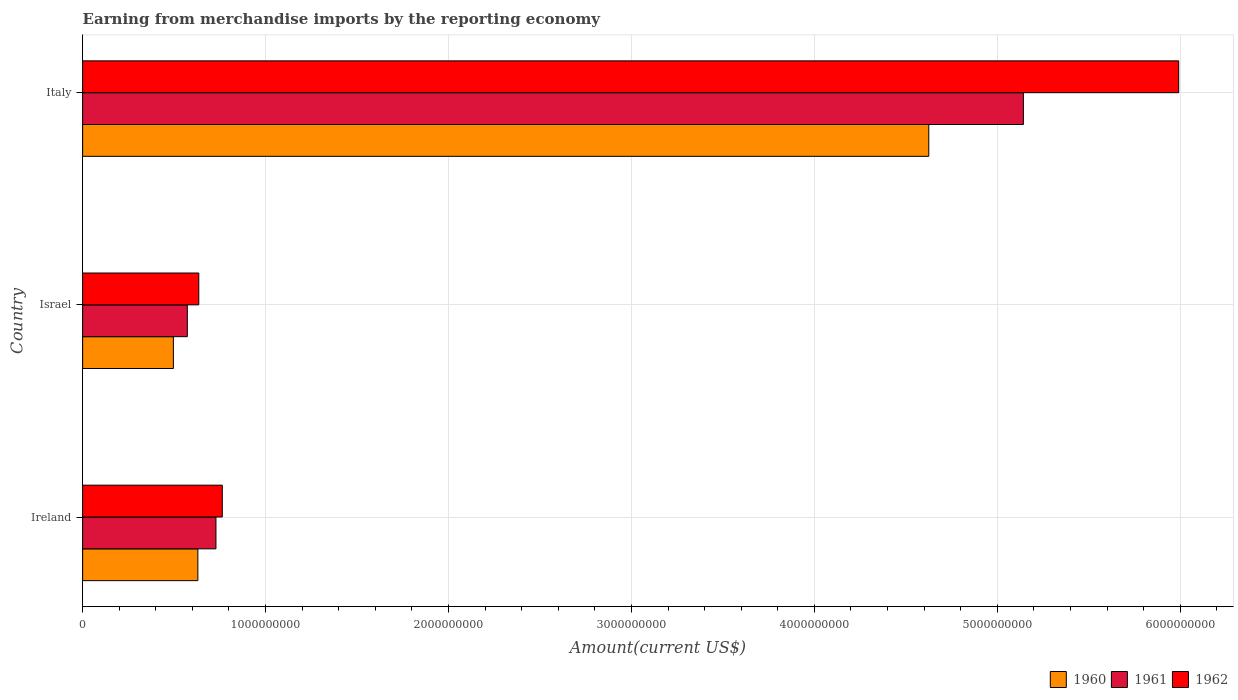How many different coloured bars are there?
Offer a very short reply. 3. Are the number of bars per tick equal to the number of legend labels?
Ensure brevity in your answer.  Yes. How many bars are there on the 2nd tick from the bottom?
Offer a terse response. 3. In how many cases, is the number of bars for a given country not equal to the number of legend labels?
Offer a very short reply. 0. What is the amount earned from merchandise imports in 1961 in Ireland?
Your answer should be very brief. 7.29e+08. Across all countries, what is the maximum amount earned from merchandise imports in 1960?
Offer a very short reply. 4.63e+09. Across all countries, what is the minimum amount earned from merchandise imports in 1960?
Offer a terse response. 4.96e+08. What is the total amount earned from merchandise imports in 1962 in the graph?
Give a very brief answer. 7.39e+09. What is the difference between the amount earned from merchandise imports in 1962 in Israel and that in Italy?
Keep it short and to the point. -5.36e+09. What is the difference between the amount earned from merchandise imports in 1962 in Israel and the amount earned from merchandise imports in 1961 in Ireland?
Your answer should be compact. -9.39e+07. What is the average amount earned from merchandise imports in 1960 per country?
Offer a very short reply. 1.92e+09. What is the difference between the amount earned from merchandise imports in 1960 and amount earned from merchandise imports in 1962 in Israel?
Offer a very short reply. -1.39e+08. What is the ratio of the amount earned from merchandise imports in 1960 in Ireland to that in Italy?
Offer a terse response. 0.14. Is the amount earned from merchandise imports in 1962 in Ireland less than that in Israel?
Your answer should be very brief. No. What is the difference between the highest and the second highest amount earned from merchandise imports in 1961?
Your answer should be very brief. 4.41e+09. What is the difference between the highest and the lowest amount earned from merchandise imports in 1960?
Give a very brief answer. 4.13e+09. Is the sum of the amount earned from merchandise imports in 1962 in Israel and Italy greater than the maximum amount earned from merchandise imports in 1960 across all countries?
Offer a very short reply. Yes. What does the 1st bar from the top in Israel represents?
Provide a short and direct response. 1962. What does the 1st bar from the bottom in Ireland represents?
Ensure brevity in your answer.  1960. Is it the case that in every country, the sum of the amount earned from merchandise imports in 1960 and amount earned from merchandise imports in 1961 is greater than the amount earned from merchandise imports in 1962?
Provide a succinct answer. Yes. How many bars are there?
Your answer should be very brief. 9. Are all the bars in the graph horizontal?
Make the answer very short. Yes. Does the graph contain any zero values?
Your answer should be compact. No. What is the title of the graph?
Offer a very short reply. Earning from merchandise imports by the reporting economy. What is the label or title of the X-axis?
Make the answer very short. Amount(current US$). What is the label or title of the Y-axis?
Give a very brief answer. Country. What is the Amount(current US$) in 1960 in Ireland?
Keep it short and to the point. 6.30e+08. What is the Amount(current US$) of 1961 in Ireland?
Your response must be concise. 7.29e+08. What is the Amount(current US$) in 1962 in Ireland?
Provide a short and direct response. 7.64e+08. What is the Amount(current US$) in 1960 in Israel?
Ensure brevity in your answer.  4.96e+08. What is the Amount(current US$) in 1961 in Israel?
Offer a very short reply. 5.72e+08. What is the Amount(current US$) of 1962 in Israel?
Your response must be concise. 6.35e+08. What is the Amount(current US$) of 1960 in Italy?
Give a very brief answer. 4.63e+09. What is the Amount(current US$) in 1961 in Italy?
Your answer should be very brief. 5.14e+09. What is the Amount(current US$) in 1962 in Italy?
Keep it short and to the point. 5.99e+09. Across all countries, what is the maximum Amount(current US$) of 1960?
Give a very brief answer. 4.63e+09. Across all countries, what is the maximum Amount(current US$) of 1961?
Your answer should be very brief. 5.14e+09. Across all countries, what is the maximum Amount(current US$) in 1962?
Make the answer very short. 5.99e+09. Across all countries, what is the minimum Amount(current US$) in 1960?
Offer a very short reply. 4.96e+08. Across all countries, what is the minimum Amount(current US$) in 1961?
Give a very brief answer. 5.72e+08. Across all countries, what is the minimum Amount(current US$) in 1962?
Your response must be concise. 6.35e+08. What is the total Amount(current US$) in 1960 in the graph?
Give a very brief answer. 5.75e+09. What is the total Amount(current US$) of 1961 in the graph?
Your answer should be very brief. 6.44e+09. What is the total Amount(current US$) in 1962 in the graph?
Your answer should be very brief. 7.39e+09. What is the difference between the Amount(current US$) of 1960 in Ireland and that in Israel?
Make the answer very short. 1.34e+08. What is the difference between the Amount(current US$) of 1961 in Ireland and that in Israel?
Offer a very short reply. 1.56e+08. What is the difference between the Amount(current US$) of 1962 in Ireland and that in Israel?
Your answer should be compact. 1.29e+08. What is the difference between the Amount(current US$) of 1960 in Ireland and that in Italy?
Ensure brevity in your answer.  -4.00e+09. What is the difference between the Amount(current US$) of 1961 in Ireland and that in Italy?
Give a very brief answer. -4.41e+09. What is the difference between the Amount(current US$) of 1962 in Ireland and that in Italy?
Make the answer very short. -5.23e+09. What is the difference between the Amount(current US$) in 1960 in Israel and that in Italy?
Ensure brevity in your answer.  -4.13e+09. What is the difference between the Amount(current US$) in 1961 in Israel and that in Italy?
Your response must be concise. -4.57e+09. What is the difference between the Amount(current US$) of 1962 in Israel and that in Italy?
Provide a succinct answer. -5.36e+09. What is the difference between the Amount(current US$) in 1960 in Ireland and the Amount(current US$) in 1961 in Israel?
Your response must be concise. 5.76e+07. What is the difference between the Amount(current US$) of 1960 in Ireland and the Amount(current US$) of 1962 in Israel?
Give a very brief answer. -5.00e+06. What is the difference between the Amount(current US$) of 1961 in Ireland and the Amount(current US$) of 1962 in Israel?
Give a very brief answer. 9.39e+07. What is the difference between the Amount(current US$) of 1960 in Ireland and the Amount(current US$) of 1961 in Italy?
Keep it short and to the point. -4.51e+09. What is the difference between the Amount(current US$) in 1960 in Ireland and the Amount(current US$) in 1962 in Italy?
Keep it short and to the point. -5.36e+09. What is the difference between the Amount(current US$) in 1961 in Ireland and the Amount(current US$) in 1962 in Italy?
Your answer should be very brief. -5.26e+09. What is the difference between the Amount(current US$) of 1960 in Israel and the Amount(current US$) of 1961 in Italy?
Provide a succinct answer. -4.65e+09. What is the difference between the Amount(current US$) in 1960 in Israel and the Amount(current US$) in 1962 in Italy?
Offer a terse response. -5.50e+09. What is the difference between the Amount(current US$) in 1961 in Israel and the Amount(current US$) in 1962 in Italy?
Provide a short and direct response. -5.42e+09. What is the average Amount(current US$) in 1960 per country?
Give a very brief answer. 1.92e+09. What is the average Amount(current US$) of 1961 per country?
Provide a succinct answer. 2.15e+09. What is the average Amount(current US$) in 1962 per country?
Offer a terse response. 2.46e+09. What is the difference between the Amount(current US$) in 1960 and Amount(current US$) in 1961 in Ireland?
Your answer should be very brief. -9.89e+07. What is the difference between the Amount(current US$) of 1960 and Amount(current US$) of 1962 in Ireland?
Offer a terse response. -1.34e+08. What is the difference between the Amount(current US$) of 1961 and Amount(current US$) of 1962 in Ireland?
Your response must be concise. -3.47e+07. What is the difference between the Amount(current US$) of 1960 and Amount(current US$) of 1961 in Israel?
Ensure brevity in your answer.  -7.62e+07. What is the difference between the Amount(current US$) in 1960 and Amount(current US$) in 1962 in Israel?
Provide a short and direct response. -1.39e+08. What is the difference between the Amount(current US$) of 1961 and Amount(current US$) of 1962 in Israel?
Your answer should be compact. -6.26e+07. What is the difference between the Amount(current US$) in 1960 and Amount(current US$) in 1961 in Italy?
Offer a very short reply. -5.17e+08. What is the difference between the Amount(current US$) in 1960 and Amount(current US$) in 1962 in Italy?
Offer a terse response. -1.37e+09. What is the difference between the Amount(current US$) in 1961 and Amount(current US$) in 1962 in Italy?
Your answer should be very brief. -8.49e+08. What is the ratio of the Amount(current US$) in 1960 in Ireland to that in Israel?
Ensure brevity in your answer.  1.27. What is the ratio of the Amount(current US$) of 1961 in Ireland to that in Israel?
Your answer should be compact. 1.27. What is the ratio of the Amount(current US$) of 1962 in Ireland to that in Israel?
Your response must be concise. 1.2. What is the ratio of the Amount(current US$) of 1960 in Ireland to that in Italy?
Keep it short and to the point. 0.14. What is the ratio of the Amount(current US$) in 1961 in Ireland to that in Italy?
Your answer should be very brief. 0.14. What is the ratio of the Amount(current US$) in 1962 in Ireland to that in Italy?
Make the answer very short. 0.13. What is the ratio of the Amount(current US$) of 1960 in Israel to that in Italy?
Provide a short and direct response. 0.11. What is the ratio of the Amount(current US$) in 1961 in Israel to that in Italy?
Ensure brevity in your answer.  0.11. What is the ratio of the Amount(current US$) in 1962 in Israel to that in Italy?
Your response must be concise. 0.11. What is the difference between the highest and the second highest Amount(current US$) in 1960?
Offer a terse response. 4.00e+09. What is the difference between the highest and the second highest Amount(current US$) of 1961?
Provide a short and direct response. 4.41e+09. What is the difference between the highest and the second highest Amount(current US$) of 1962?
Ensure brevity in your answer.  5.23e+09. What is the difference between the highest and the lowest Amount(current US$) of 1960?
Offer a very short reply. 4.13e+09. What is the difference between the highest and the lowest Amount(current US$) of 1961?
Ensure brevity in your answer.  4.57e+09. What is the difference between the highest and the lowest Amount(current US$) in 1962?
Give a very brief answer. 5.36e+09. 